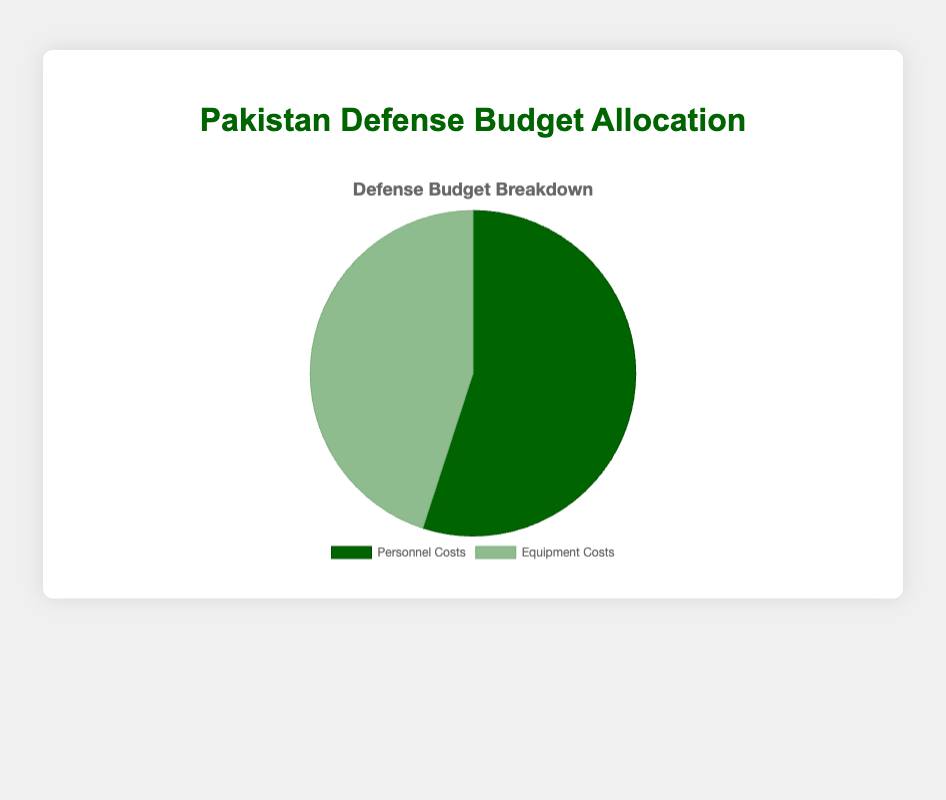Which category has a higher allocation in the defense budget? By looking at the pie chart, the "Personnel Costs" slice is larger than the "Equipment Costs" slice.
Answer: Personnel Costs What percentage of the defense budget is allocated to equipment costs? The pie chart shows that the allocation for Equipment Costs is 45%.
Answer: 45% How much more is allocated to personnel costs compared to equipment costs? The allocation for Personnel Costs is 55% while Equipment Costs is 45%. The difference is 55% - 45% = 10%.
Answer: 10% If the total defense budget is $100 million, how much is allocated to personnel costs? Since 55% of the budget is allocated to Personnel Costs, 0.55 * 100 million = $55 million.
Answer: $55 million What is the ratio of personnel costs to equipment costs in the defense budget? The percentage for Personnel Costs is 55% and for Equipment Costs is 45%. The ratio is 55:45, which simplifies to 11:9.
Answer: 11:9 What would the total percentage be if both categories were combined? In a pie chart, the sum of all parts equals 100%. Therefore, the combined percentage of Personnel Costs and Equipment Costs is 55% + 45% = 100%.
Answer: 100% Which category is represented by a darker shade of green in the pie chart? By observing the colors in the pie chart, "Personnel Costs" is shown in a darker shade of green compared to "Equipment Costs".
Answer: Personnel Costs If $20 million more was allocated to equipment costs, would it surpass personnel costs in the budget? Adding $20 million to Equipment Costs would make it $20 million + 45% of the current budget. If the total budget is $100 million, Equipment Costs would become $20 million + $45 million = $65 million. This surpasses Personnel Costs at $55 million.
Answer: Yes What percentage is the difference between the two allocations? The difference in allocation percentages is 55% (Personnel Costs) - 45% (Equipment Costs) = 10%.
Answer: 10% Does the pie chart show an equal allocation for both personnel and equipment costs? The pie chart depicts different allocations: Personnel Costs at 55% and Equipment Costs at 45%. Therefore, it is not equal.
Answer: No 